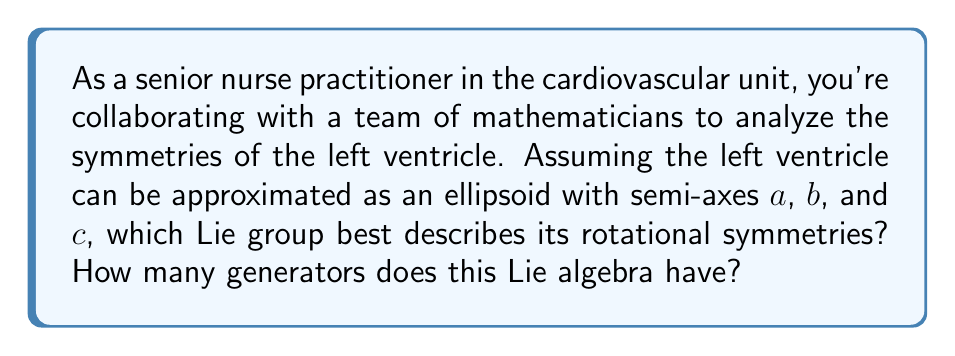What is the answer to this math problem? To analyze the symmetries of the left ventricle using Lie group theory, we need to consider the following steps:

1) The left ventricle is approximated as an ellipsoid. An ellipsoid is described by the equation:

   $$\frac{x^2}{a^2} + \frac{y^2}{b^2} + \frac{z^2}{c^2} = 1$$

   where $a$, $b$, and $c$ are the semi-axes lengths.

2) The symmetry group of an object is the group of transformations that leave the object invariant. For an ellipsoid, these are rotations about its principal axes.

3) If $a = b = c$, the ellipsoid becomes a sphere, which has the rotational symmetry group SO(3) (Special Orthogonal group in 3 dimensions).

4) If $a = b \neq c$, the ellipsoid has rotational symmetry around the z-axis, described by the group SO(2).

5) If $a \neq b \neq c$, the ellipsoid only has discrete rotational symmetries (rotations by 180° about each axis), which don't form a continuous Lie group.

6) In the context of a heart chamber, it's most realistic to assume $a \neq b \neq c$, as the left ventricle is not perfectly symmetric.

7) However, if we consider small deformations or approximate symmetries, we can model the ventricle's symmetries using the group SO(2), representing rotations around its long axis.

8) The Lie algebra associated with SO(2) is so(2), which consists of 2x2 skew-symmetric matrices.

9) The dimension of so(2), which is equal to the number of generators, is 1. This generator can be represented as:

   $$\begin{pmatrix}
   0 & -1 \\
   1 & 0
   \end{pmatrix}$$

Therefore, the Lie group that best describes the rotational symmetries of the left ventricle (approximated as an ellipsoid) is SO(2), and its corresponding Lie algebra so(2) has 1 generator.
Answer: The Lie group SO(2) best describes the rotational symmetries of the left ventricle, and its corresponding Lie algebra so(2) has 1 generator. 